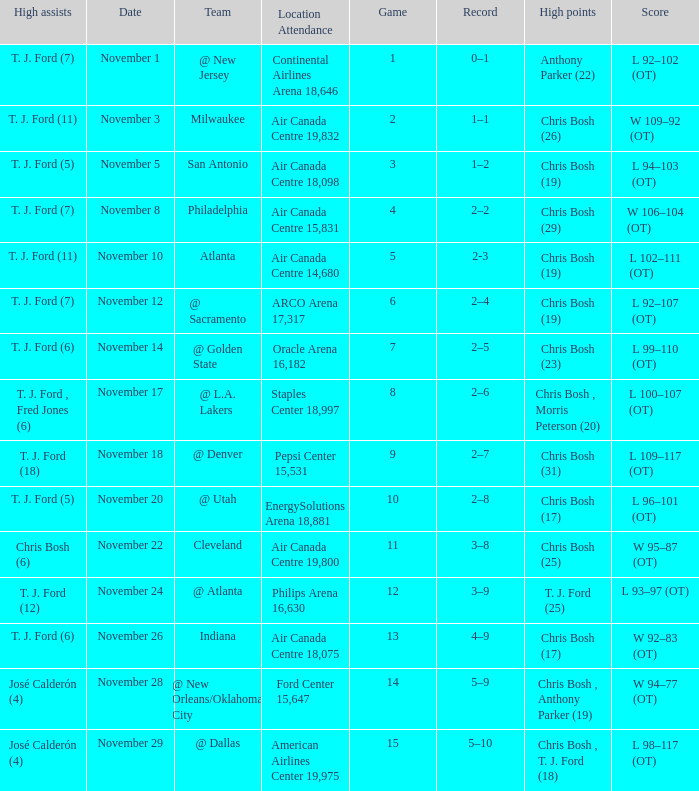What team played on November 28? @ New Orleans/Oklahoma City. 